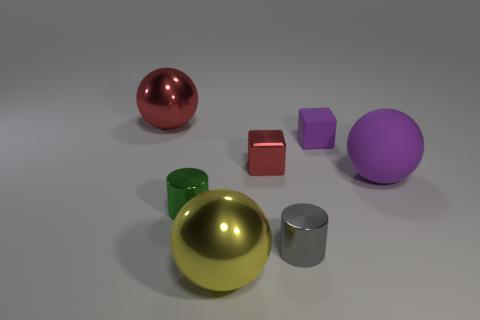Add 3 small metal objects. How many objects exist? 10 Subtract all cylinders. How many objects are left? 5 Add 2 tiny blocks. How many tiny blocks are left? 4 Add 4 purple rubber balls. How many purple rubber balls exist? 5 Subtract 0 blue spheres. How many objects are left? 7 Subtract all small gray cylinders. Subtract all small green shiny cylinders. How many objects are left? 5 